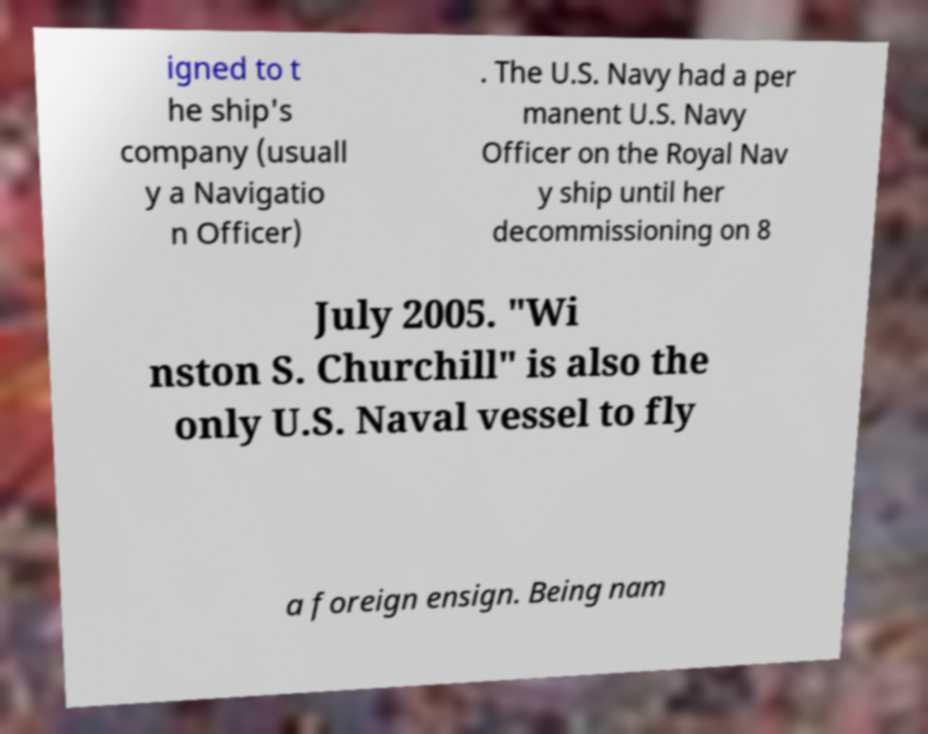There's text embedded in this image that I need extracted. Can you transcribe it verbatim? igned to t he ship's company (usuall y a Navigatio n Officer) . The U.S. Navy had a per manent U.S. Navy Officer on the Royal Nav y ship until her decommissioning on 8 July 2005. "Wi nston S. Churchill" is also the only U.S. Naval vessel to fly a foreign ensign. Being nam 